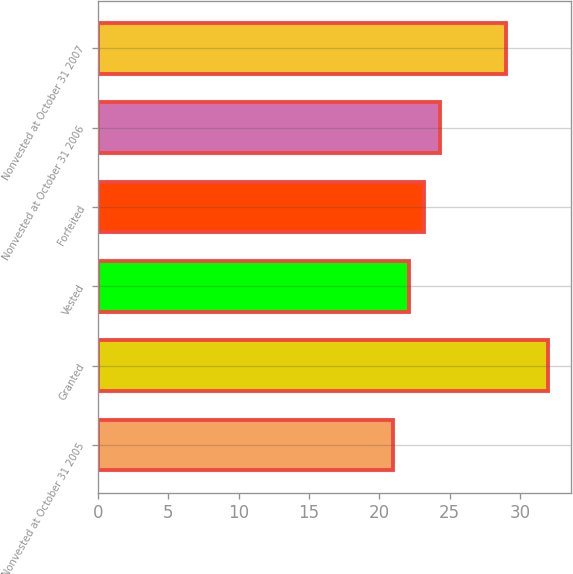Convert chart. <chart><loc_0><loc_0><loc_500><loc_500><bar_chart><fcel>Nonvested at October 31 2005<fcel>Granted<fcel>Vested<fcel>Forfeited<fcel>Nonvested at October 31 2006<fcel>Nonvested at October 31 2007<nl><fcel>21<fcel>32<fcel>22.1<fcel>23.2<fcel>24.3<fcel>29<nl></chart> 